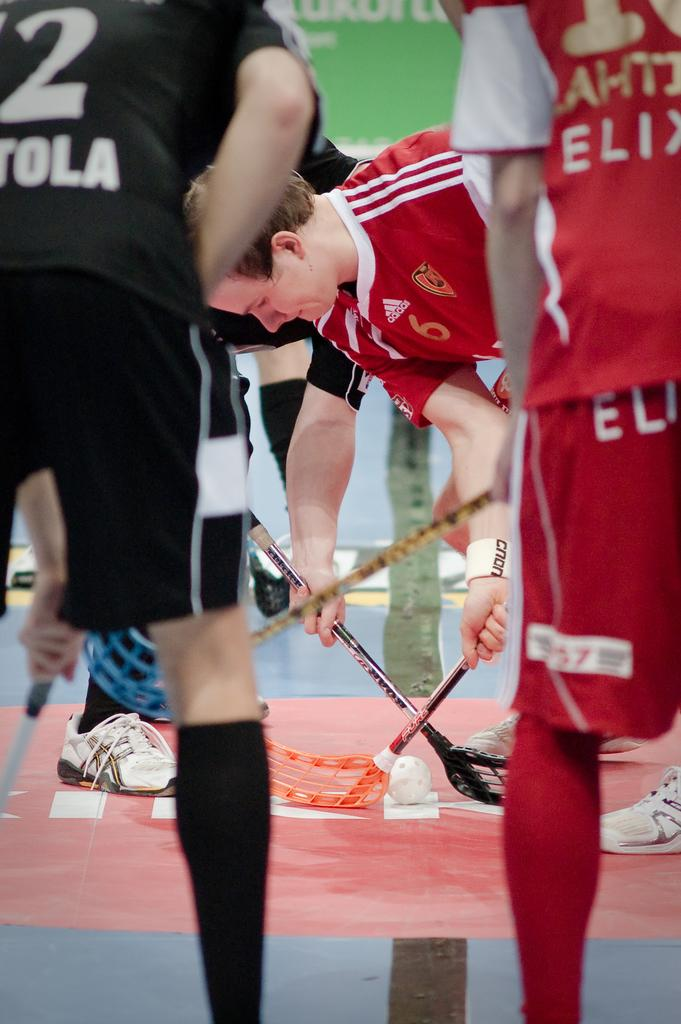<image>
Summarize the visual content of the image. The number 6 player on the Addidas sponsored lacrosse team is bent over the ball waiting for the call to start. 